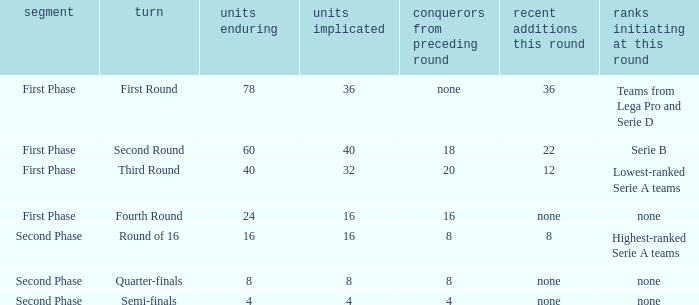During the first phase portion of phase and having 16 clubs involved; what would you find for the winners from previous round? 16.0. 